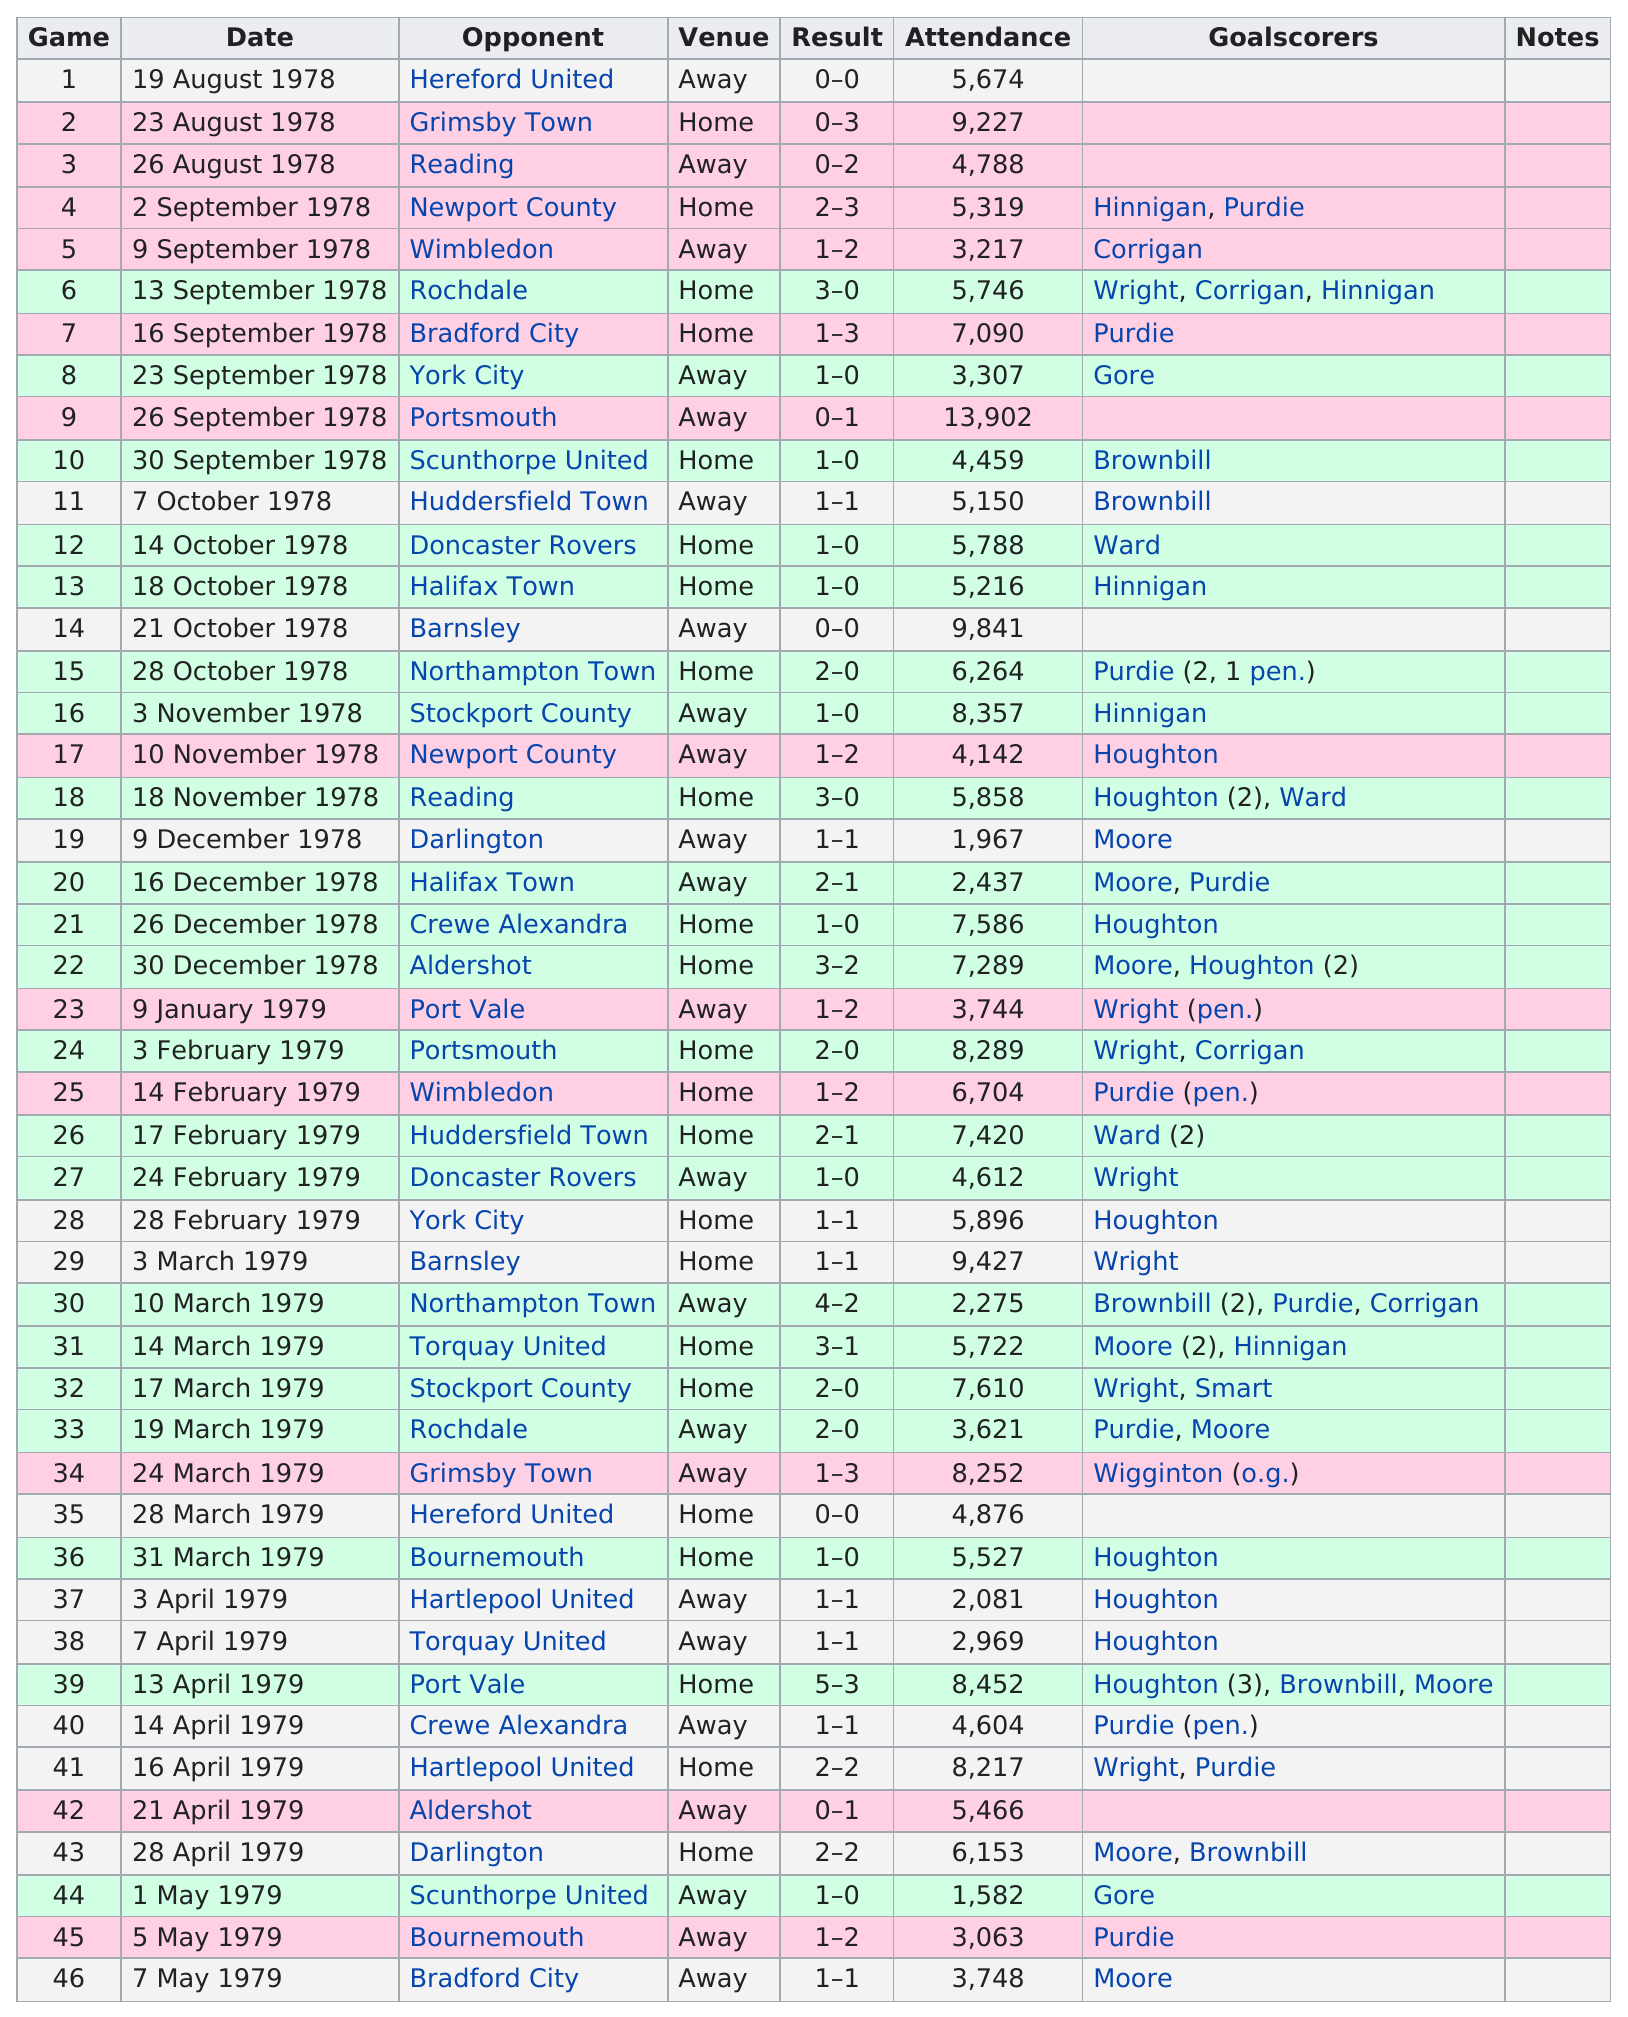Outline some significant characteristics in this image. The longest consecutive win streak was 4 games, and that was the record. The least attended game was held on May 1, 1979. There were 11 games that had attendance of at least 7,500 people. I have determined that Hinnigan scored a total of 5 goals throughout this season. I declare that in September 1978, a total of 7 games were played. 